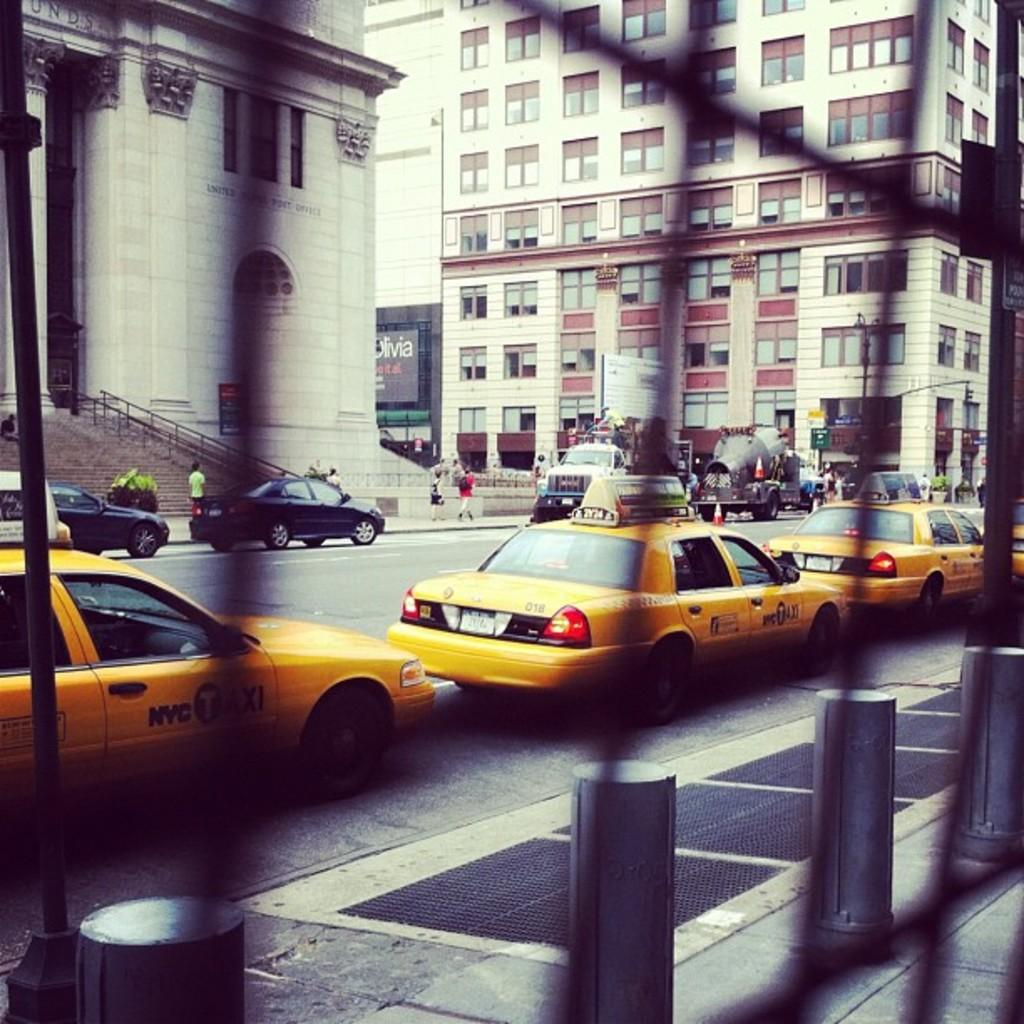What can be seen in the image that might be used for support or safety? There is a railing in the image that might be used for support or safety. What is happening on the road in the image? Vehicles on the road are visible in the image. Who or what can be seen in the image besides the railing and vehicles? People and buildings are visible in the image. What type of yoke is being used by the person in the image? There is no person using a yoke in the image. 